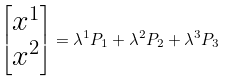Convert formula to latex. <formula><loc_0><loc_0><loc_500><loc_500>\begin{bmatrix} x ^ { 1 } \\ x ^ { 2 } \end{bmatrix} = \lambda ^ { 1 } P _ { 1 } + \lambda ^ { 2 } P _ { 2 } + \lambda ^ { 3 } P _ { 3 }</formula> 